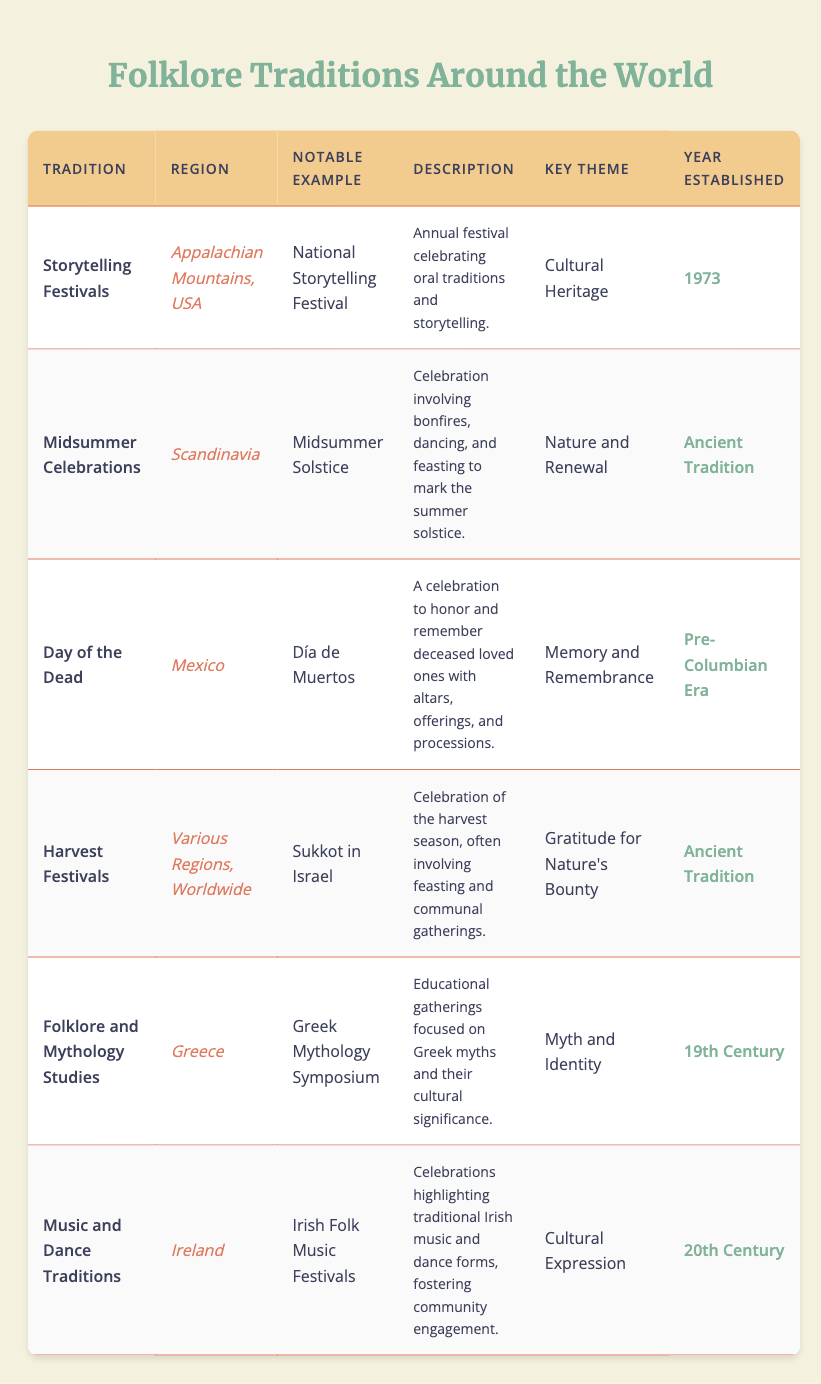What is the tradition celebrated in the Appalachian Mountains, USA? The table lists "Storytelling Festivals" as the tradition in that region.
Answer: Storytelling Festivals Which festival marks the Midsummer Celebrations in Scandinavia? The notable example of Midsummer Celebrations listed in the table is "Midsummer Solstice".
Answer: Midsummer Solstice Is the "Day of the Dead" associated with memory and remembrance? The table shows that the key theme for "Day of the Dead" is "Memory and Remembrance", confirming that it is indeed associated with this theme.
Answer: Yes How many traditions were established before the 20th century? By counting the years established: "Pre-Columbian Era", "Ancient Tradition", "Ancient Tradition", and "19th Century", we find 4 traditions established before 20th century.
Answer: 4 What are the key themes of the Midsummer Celebrations and Harvest Festivals? The table lists "Nature and Renewal" for Midsummer Celebrations and "Gratitude for Nature's Bounty" for Harvest Festivals.
Answer: Nature and Renewal; Gratitude for Nature's Bounty Are storytelling festivals celebrated globally? The table specifies that "Storytelling Festivals" are held in the Appalachian Mountains, USA, indicating it is not a global celebration.
Answer: No Identify the tradition that began in the 19th century and its region. The table indicates "Folklore and Mythology Studies" is the tradition from Greece established in the 19th century.
Answer: Folklore and Mythology Studies; Greece What is the notable example of the Music and Dance Traditions in Ireland? The table specifies "Irish Folk Music Festivals" as the notable example for the Music and Dance Traditions.
Answer: Irish Folk Music Festivals Which tradition focuses on celebrating oral traditions and storytelling? The table states "Storytelling Festivals" is the tradition specifically celebrating oral traditions and storytelling.
Answer: Storytelling Festivals 